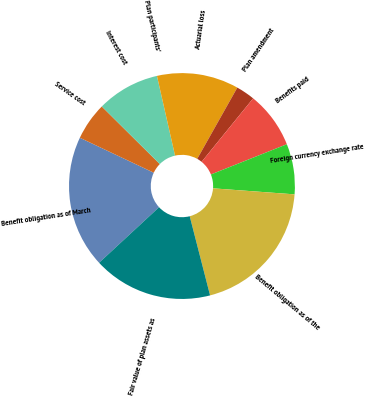<chart> <loc_0><loc_0><loc_500><loc_500><pie_chart><fcel>Benefit obligation as of March<fcel>Service cost<fcel>Interest cost<fcel>Plan participants'<fcel>Actuarial loss<fcel>Plan amendment<fcel>Benefits paid<fcel>Foreign currency exchange rate<fcel>Benefit obligation as of the<fcel>Fair value of plan assets as<nl><fcel>18.92%<fcel>5.41%<fcel>9.01%<fcel>0.0%<fcel>11.71%<fcel>2.7%<fcel>8.11%<fcel>7.21%<fcel>19.82%<fcel>17.12%<nl></chart> 